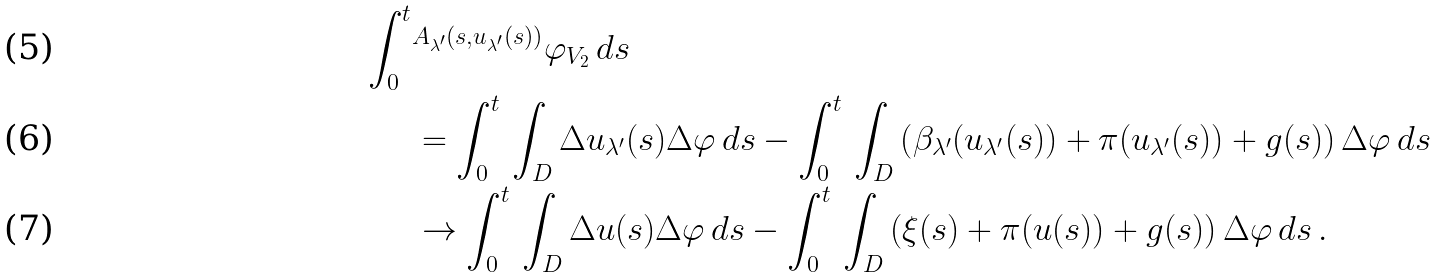<formula> <loc_0><loc_0><loc_500><loc_500>\int _ { 0 } ^ { t } & ^ { A _ { \lambda ^ { \prime } } ( s , u _ { \lambda ^ { \prime } } ( s ) ) } { \varphi } _ { V _ { 2 } } \, d s \\ & = \int _ { 0 } ^ { t } \, \int _ { D } \Delta u _ { \lambda ^ { \prime } } ( s ) \Delta \varphi \, d s - \int _ { 0 } ^ { t } \, \int _ { D } \left ( \beta _ { \lambda ^ { \prime } } ( u _ { \lambda ^ { \prime } } ( s ) ) + \pi ( u _ { \lambda ^ { \prime } } ( s ) ) + g ( s ) \right ) \Delta \varphi \, d s \\ & \to \int _ { 0 } ^ { t } \, \int _ { D } \Delta u ( s ) \Delta \varphi \, d s - \int _ { 0 } ^ { t } \, \int _ { D } \left ( \xi ( s ) + \pi ( u ( s ) ) + g ( s ) \right ) \Delta \varphi \, d s \, .</formula> 